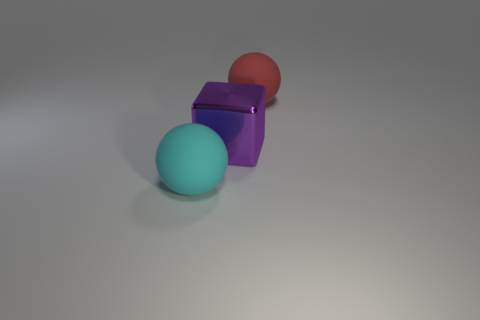What number of things are big rubber balls that are right of the large purple block or rubber objects that are on the left side of the large red rubber sphere?
Your answer should be very brief. 2. How many other objects are the same color as the big block?
Your response must be concise. 0. There is a big cyan matte object; is it the same shape as the matte object to the right of the large cyan rubber object?
Make the answer very short. Yes. Are there fewer big red balls behind the big red object than big red objects on the right side of the cyan thing?
Ensure brevity in your answer.  Yes. There is another thing that is the same shape as the big red matte object; what material is it?
Offer a very short reply. Rubber. Is there any other thing that has the same material as the cube?
Keep it short and to the point. No. There is a object that is the same material as the red ball; what is its shape?
Make the answer very short. Sphere. How many other large red matte things have the same shape as the red matte object?
Your answer should be compact. 0. There is a rubber object left of the ball to the right of the big purple metallic block; what is its shape?
Provide a succinct answer. Sphere. There is a cyan object left of the purple object; does it have the same size as the big metal block?
Your answer should be very brief. Yes. 